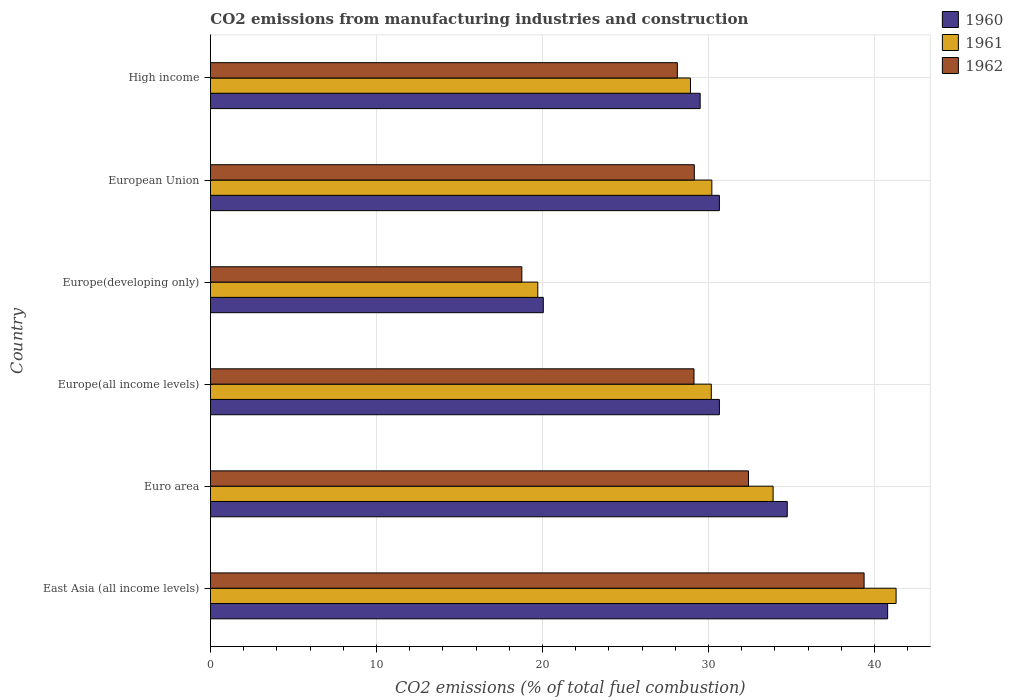How many different coloured bars are there?
Ensure brevity in your answer.  3. How many groups of bars are there?
Ensure brevity in your answer.  6. Are the number of bars per tick equal to the number of legend labels?
Provide a short and direct response. Yes. How many bars are there on the 5th tick from the bottom?
Keep it short and to the point. 3. What is the label of the 4th group of bars from the top?
Offer a terse response. Europe(all income levels). In how many cases, is the number of bars for a given country not equal to the number of legend labels?
Offer a terse response. 0. What is the amount of CO2 emitted in 1962 in Europe(developing only)?
Keep it short and to the point. 18.76. Across all countries, what is the maximum amount of CO2 emitted in 1960?
Your response must be concise. 40.79. Across all countries, what is the minimum amount of CO2 emitted in 1962?
Your response must be concise. 18.76. In which country was the amount of CO2 emitted in 1961 maximum?
Provide a short and direct response. East Asia (all income levels). In which country was the amount of CO2 emitted in 1962 minimum?
Ensure brevity in your answer.  Europe(developing only). What is the total amount of CO2 emitted in 1961 in the graph?
Give a very brief answer. 184.19. What is the difference between the amount of CO2 emitted in 1962 in Euro area and that in High income?
Offer a terse response. 4.29. What is the difference between the amount of CO2 emitted in 1962 in East Asia (all income levels) and the amount of CO2 emitted in 1960 in Europe(developing only)?
Ensure brevity in your answer.  19.32. What is the average amount of CO2 emitted in 1961 per country?
Offer a very short reply. 30.7. What is the difference between the amount of CO2 emitted in 1962 and amount of CO2 emitted in 1961 in European Union?
Offer a very short reply. -1.05. What is the ratio of the amount of CO2 emitted in 1962 in Euro area to that in European Union?
Provide a short and direct response. 1.11. Is the amount of CO2 emitted in 1960 in Europe(developing only) less than that in European Union?
Your answer should be very brief. Yes. Is the difference between the amount of CO2 emitted in 1962 in Europe(all income levels) and High income greater than the difference between the amount of CO2 emitted in 1961 in Europe(all income levels) and High income?
Give a very brief answer. No. What is the difference between the highest and the second highest amount of CO2 emitted in 1962?
Give a very brief answer. 6.96. What is the difference between the highest and the lowest amount of CO2 emitted in 1962?
Your answer should be compact. 20.62. In how many countries, is the amount of CO2 emitted in 1961 greater than the average amount of CO2 emitted in 1961 taken over all countries?
Ensure brevity in your answer.  2. What does the 2nd bar from the top in Europe(all income levels) represents?
Offer a terse response. 1961. What does the 3rd bar from the bottom in East Asia (all income levels) represents?
Ensure brevity in your answer.  1962. How many bars are there?
Offer a very short reply. 18. Are all the bars in the graph horizontal?
Your answer should be very brief. Yes. What is the difference between two consecutive major ticks on the X-axis?
Ensure brevity in your answer.  10. Are the values on the major ticks of X-axis written in scientific E-notation?
Give a very brief answer. No. Does the graph contain grids?
Offer a terse response. Yes. Where does the legend appear in the graph?
Ensure brevity in your answer.  Top right. How are the legend labels stacked?
Offer a terse response. Vertical. What is the title of the graph?
Keep it short and to the point. CO2 emissions from manufacturing industries and construction. What is the label or title of the X-axis?
Your answer should be compact. CO2 emissions (% of total fuel combustion). What is the label or title of the Y-axis?
Your response must be concise. Country. What is the CO2 emissions (% of total fuel combustion) of 1960 in East Asia (all income levels)?
Offer a terse response. 40.79. What is the CO2 emissions (% of total fuel combustion) of 1961 in East Asia (all income levels)?
Offer a terse response. 41.3. What is the CO2 emissions (% of total fuel combustion) of 1962 in East Asia (all income levels)?
Provide a short and direct response. 39.37. What is the CO2 emissions (% of total fuel combustion) in 1960 in Euro area?
Ensure brevity in your answer.  34.75. What is the CO2 emissions (% of total fuel combustion) in 1961 in Euro area?
Your answer should be compact. 33.89. What is the CO2 emissions (% of total fuel combustion) in 1962 in Euro area?
Provide a short and direct response. 32.41. What is the CO2 emissions (% of total fuel combustion) of 1960 in Europe(all income levels)?
Your answer should be very brief. 30.66. What is the CO2 emissions (% of total fuel combustion) in 1961 in Europe(all income levels)?
Ensure brevity in your answer.  30.17. What is the CO2 emissions (% of total fuel combustion) of 1962 in Europe(all income levels)?
Your answer should be very brief. 29.13. What is the CO2 emissions (% of total fuel combustion) in 1960 in Europe(developing only)?
Your answer should be compact. 20.05. What is the CO2 emissions (% of total fuel combustion) in 1961 in Europe(developing only)?
Offer a very short reply. 19.72. What is the CO2 emissions (% of total fuel combustion) in 1962 in Europe(developing only)?
Your answer should be very brief. 18.76. What is the CO2 emissions (% of total fuel combustion) in 1960 in European Union?
Ensure brevity in your answer.  30.66. What is the CO2 emissions (% of total fuel combustion) in 1961 in European Union?
Your response must be concise. 30.2. What is the CO2 emissions (% of total fuel combustion) of 1962 in European Union?
Offer a very short reply. 29.15. What is the CO2 emissions (% of total fuel combustion) of 1960 in High income?
Ensure brevity in your answer.  29.5. What is the CO2 emissions (% of total fuel combustion) of 1961 in High income?
Make the answer very short. 28.92. What is the CO2 emissions (% of total fuel combustion) of 1962 in High income?
Offer a terse response. 28.12. Across all countries, what is the maximum CO2 emissions (% of total fuel combustion) of 1960?
Give a very brief answer. 40.79. Across all countries, what is the maximum CO2 emissions (% of total fuel combustion) in 1961?
Give a very brief answer. 41.3. Across all countries, what is the maximum CO2 emissions (% of total fuel combustion) of 1962?
Provide a short and direct response. 39.37. Across all countries, what is the minimum CO2 emissions (% of total fuel combustion) in 1960?
Your response must be concise. 20.05. Across all countries, what is the minimum CO2 emissions (% of total fuel combustion) of 1961?
Give a very brief answer. 19.72. Across all countries, what is the minimum CO2 emissions (% of total fuel combustion) in 1962?
Keep it short and to the point. 18.76. What is the total CO2 emissions (% of total fuel combustion) in 1960 in the graph?
Offer a very short reply. 186.4. What is the total CO2 emissions (% of total fuel combustion) in 1961 in the graph?
Make the answer very short. 184.19. What is the total CO2 emissions (% of total fuel combustion) of 1962 in the graph?
Offer a very short reply. 176.93. What is the difference between the CO2 emissions (% of total fuel combustion) in 1960 in East Asia (all income levels) and that in Euro area?
Your response must be concise. 6.05. What is the difference between the CO2 emissions (% of total fuel combustion) of 1961 in East Asia (all income levels) and that in Euro area?
Your response must be concise. 7.41. What is the difference between the CO2 emissions (% of total fuel combustion) in 1962 in East Asia (all income levels) and that in Euro area?
Give a very brief answer. 6.96. What is the difference between the CO2 emissions (% of total fuel combustion) of 1960 in East Asia (all income levels) and that in Europe(all income levels)?
Ensure brevity in your answer.  10.13. What is the difference between the CO2 emissions (% of total fuel combustion) in 1961 in East Asia (all income levels) and that in Europe(all income levels)?
Keep it short and to the point. 11.13. What is the difference between the CO2 emissions (% of total fuel combustion) of 1962 in East Asia (all income levels) and that in Europe(all income levels)?
Your response must be concise. 10.25. What is the difference between the CO2 emissions (% of total fuel combustion) of 1960 in East Asia (all income levels) and that in Europe(developing only)?
Make the answer very short. 20.74. What is the difference between the CO2 emissions (% of total fuel combustion) of 1961 in East Asia (all income levels) and that in Europe(developing only)?
Offer a terse response. 21.58. What is the difference between the CO2 emissions (% of total fuel combustion) in 1962 in East Asia (all income levels) and that in Europe(developing only)?
Keep it short and to the point. 20.62. What is the difference between the CO2 emissions (% of total fuel combustion) in 1960 in East Asia (all income levels) and that in European Union?
Your answer should be very brief. 10.13. What is the difference between the CO2 emissions (% of total fuel combustion) in 1961 in East Asia (all income levels) and that in European Union?
Provide a succinct answer. 11.1. What is the difference between the CO2 emissions (% of total fuel combustion) of 1962 in East Asia (all income levels) and that in European Union?
Give a very brief answer. 10.23. What is the difference between the CO2 emissions (% of total fuel combustion) of 1960 in East Asia (all income levels) and that in High income?
Provide a short and direct response. 11.29. What is the difference between the CO2 emissions (% of total fuel combustion) of 1961 in East Asia (all income levels) and that in High income?
Provide a short and direct response. 12.38. What is the difference between the CO2 emissions (% of total fuel combustion) of 1962 in East Asia (all income levels) and that in High income?
Keep it short and to the point. 11.25. What is the difference between the CO2 emissions (% of total fuel combustion) in 1960 in Euro area and that in Europe(all income levels)?
Offer a terse response. 4.09. What is the difference between the CO2 emissions (% of total fuel combustion) of 1961 in Euro area and that in Europe(all income levels)?
Your answer should be very brief. 3.72. What is the difference between the CO2 emissions (% of total fuel combustion) of 1962 in Euro area and that in Europe(all income levels)?
Offer a terse response. 3.28. What is the difference between the CO2 emissions (% of total fuel combustion) of 1960 in Euro area and that in Europe(developing only)?
Your answer should be very brief. 14.7. What is the difference between the CO2 emissions (% of total fuel combustion) of 1961 in Euro area and that in Europe(developing only)?
Ensure brevity in your answer.  14.18. What is the difference between the CO2 emissions (% of total fuel combustion) of 1962 in Euro area and that in Europe(developing only)?
Make the answer very short. 13.65. What is the difference between the CO2 emissions (% of total fuel combustion) of 1960 in Euro area and that in European Union?
Your response must be concise. 4.09. What is the difference between the CO2 emissions (% of total fuel combustion) in 1961 in Euro area and that in European Union?
Offer a very short reply. 3.69. What is the difference between the CO2 emissions (% of total fuel combustion) of 1962 in Euro area and that in European Union?
Your answer should be very brief. 3.26. What is the difference between the CO2 emissions (% of total fuel combustion) of 1960 in Euro area and that in High income?
Your response must be concise. 5.25. What is the difference between the CO2 emissions (% of total fuel combustion) of 1961 in Euro area and that in High income?
Offer a very short reply. 4.98. What is the difference between the CO2 emissions (% of total fuel combustion) of 1962 in Euro area and that in High income?
Ensure brevity in your answer.  4.29. What is the difference between the CO2 emissions (% of total fuel combustion) of 1960 in Europe(all income levels) and that in Europe(developing only)?
Your answer should be compact. 10.61. What is the difference between the CO2 emissions (% of total fuel combustion) of 1961 in Europe(all income levels) and that in Europe(developing only)?
Your answer should be compact. 10.45. What is the difference between the CO2 emissions (% of total fuel combustion) in 1962 in Europe(all income levels) and that in Europe(developing only)?
Your answer should be very brief. 10.37. What is the difference between the CO2 emissions (% of total fuel combustion) of 1960 in Europe(all income levels) and that in European Union?
Provide a succinct answer. 0. What is the difference between the CO2 emissions (% of total fuel combustion) of 1961 in Europe(all income levels) and that in European Union?
Offer a terse response. -0.03. What is the difference between the CO2 emissions (% of total fuel combustion) in 1962 in Europe(all income levels) and that in European Union?
Ensure brevity in your answer.  -0.02. What is the difference between the CO2 emissions (% of total fuel combustion) of 1960 in Europe(all income levels) and that in High income?
Your answer should be compact. 1.16. What is the difference between the CO2 emissions (% of total fuel combustion) in 1961 in Europe(all income levels) and that in High income?
Give a very brief answer. 1.25. What is the difference between the CO2 emissions (% of total fuel combustion) in 1960 in Europe(developing only) and that in European Union?
Keep it short and to the point. -10.61. What is the difference between the CO2 emissions (% of total fuel combustion) in 1961 in Europe(developing only) and that in European Union?
Ensure brevity in your answer.  -10.48. What is the difference between the CO2 emissions (% of total fuel combustion) in 1962 in Europe(developing only) and that in European Union?
Make the answer very short. -10.39. What is the difference between the CO2 emissions (% of total fuel combustion) in 1960 in Europe(developing only) and that in High income?
Make the answer very short. -9.45. What is the difference between the CO2 emissions (% of total fuel combustion) of 1961 in Europe(developing only) and that in High income?
Offer a terse response. -9.2. What is the difference between the CO2 emissions (% of total fuel combustion) in 1962 in Europe(developing only) and that in High income?
Keep it short and to the point. -9.37. What is the difference between the CO2 emissions (% of total fuel combustion) of 1960 in European Union and that in High income?
Keep it short and to the point. 1.16. What is the difference between the CO2 emissions (% of total fuel combustion) of 1961 in European Union and that in High income?
Your answer should be compact. 1.29. What is the difference between the CO2 emissions (% of total fuel combustion) of 1962 in European Union and that in High income?
Ensure brevity in your answer.  1.02. What is the difference between the CO2 emissions (% of total fuel combustion) in 1960 in East Asia (all income levels) and the CO2 emissions (% of total fuel combustion) in 1961 in Euro area?
Ensure brevity in your answer.  6.9. What is the difference between the CO2 emissions (% of total fuel combustion) of 1960 in East Asia (all income levels) and the CO2 emissions (% of total fuel combustion) of 1962 in Euro area?
Your answer should be very brief. 8.38. What is the difference between the CO2 emissions (% of total fuel combustion) of 1961 in East Asia (all income levels) and the CO2 emissions (% of total fuel combustion) of 1962 in Euro area?
Give a very brief answer. 8.89. What is the difference between the CO2 emissions (% of total fuel combustion) in 1960 in East Asia (all income levels) and the CO2 emissions (% of total fuel combustion) in 1961 in Europe(all income levels)?
Provide a short and direct response. 10.62. What is the difference between the CO2 emissions (% of total fuel combustion) of 1960 in East Asia (all income levels) and the CO2 emissions (% of total fuel combustion) of 1962 in Europe(all income levels)?
Your answer should be compact. 11.66. What is the difference between the CO2 emissions (% of total fuel combustion) of 1961 in East Asia (all income levels) and the CO2 emissions (% of total fuel combustion) of 1962 in Europe(all income levels)?
Your answer should be compact. 12.17. What is the difference between the CO2 emissions (% of total fuel combustion) in 1960 in East Asia (all income levels) and the CO2 emissions (% of total fuel combustion) in 1961 in Europe(developing only)?
Your answer should be very brief. 21.07. What is the difference between the CO2 emissions (% of total fuel combustion) in 1960 in East Asia (all income levels) and the CO2 emissions (% of total fuel combustion) in 1962 in Europe(developing only)?
Ensure brevity in your answer.  22.03. What is the difference between the CO2 emissions (% of total fuel combustion) in 1961 in East Asia (all income levels) and the CO2 emissions (% of total fuel combustion) in 1962 in Europe(developing only)?
Your answer should be compact. 22.54. What is the difference between the CO2 emissions (% of total fuel combustion) of 1960 in East Asia (all income levels) and the CO2 emissions (% of total fuel combustion) of 1961 in European Union?
Make the answer very short. 10.59. What is the difference between the CO2 emissions (% of total fuel combustion) in 1960 in East Asia (all income levels) and the CO2 emissions (% of total fuel combustion) in 1962 in European Union?
Give a very brief answer. 11.64. What is the difference between the CO2 emissions (% of total fuel combustion) in 1961 in East Asia (all income levels) and the CO2 emissions (% of total fuel combustion) in 1962 in European Union?
Ensure brevity in your answer.  12.15. What is the difference between the CO2 emissions (% of total fuel combustion) of 1960 in East Asia (all income levels) and the CO2 emissions (% of total fuel combustion) of 1961 in High income?
Keep it short and to the point. 11.88. What is the difference between the CO2 emissions (% of total fuel combustion) of 1960 in East Asia (all income levels) and the CO2 emissions (% of total fuel combustion) of 1962 in High income?
Provide a short and direct response. 12.67. What is the difference between the CO2 emissions (% of total fuel combustion) of 1961 in East Asia (all income levels) and the CO2 emissions (% of total fuel combustion) of 1962 in High income?
Offer a very short reply. 13.18. What is the difference between the CO2 emissions (% of total fuel combustion) of 1960 in Euro area and the CO2 emissions (% of total fuel combustion) of 1961 in Europe(all income levels)?
Give a very brief answer. 4.58. What is the difference between the CO2 emissions (% of total fuel combustion) of 1960 in Euro area and the CO2 emissions (% of total fuel combustion) of 1962 in Europe(all income levels)?
Ensure brevity in your answer.  5.62. What is the difference between the CO2 emissions (% of total fuel combustion) in 1961 in Euro area and the CO2 emissions (% of total fuel combustion) in 1962 in Europe(all income levels)?
Your answer should be very brief. 4.77. What is the difference between the CO2 emissions (% of total fuel combustion) in 1960 in Euro area and the CO2 emissions (% of total fuel combustion) in 1961 in Europe(developing only)?
Provide a succinct answer. 15.03. What is the difference between the CO2 emissions (% of total fuel combustion) of 1960 in Euro area and the CO2 emissions (% of total fuel combustion) of 1962 in Europe(developing only)?
Provide a succinct answer. 15.99. What is the difference between the CO2 emissions (% of total fuel combustion) of 1961 in Euro area and the CO2 emissions (% of total fuel combustion) of 1962 in Europe(developing only)?
Your answer should be compact. 15.14. What is the difference between the CO2 emissions (% of total fuel combustion) in 1960 in Euro area and the CO2 emissions (% of total fuel combustion) in 1961 in European Union?
Give a very brief answer. 4.54. What is the difference between the CO2 emissions (% of total fuel combustion) in 1960 in Euro area and the CO2 emissions (% of total fuel combustion) in 1962 in European Union?
Your answer should be compact. 5.6. What is the difference between the CO2 emissions (% of total fuel combustion) in 1961 in Euro area and the CO2 emissions (% of total fuel combustion) in 1962 in European Union?
Keep it short and to the point. 4.75. What is the difference between the CO2 emissions (% of total fuel combustion) in 1960 in Euro area and the CO2 emissions (% of total fuel combustion) in 1961 in High income?
Your response must be concise. 5.83. What is the difference between the CO2 emissions (% of total fuel combustion) of 1960 in Euro area and the CO2 emissions (% of total fuel combustion) of 1962 in High income?
Your answer should be compact. 6.62. What is the difference between the CO2 emissions (% of total fuel combustion) in 1961 in Euro area and the CO2 emissions (% of total fuel combustion) in 1962 in High income?
Offer a terse response. 5.77. What is the difference between the CO2 emissions (% of total fuel combustion) of 1960 in Europe(all income levels) and the CO2 emissions (% of total fuel combustion) of 1961 in Europe(developing only)?
Offer a terse response. 10.94. What is the difference between the CO2 emissions (% of total fuel combustion) in 1961 in Europe(all income levels) and the CO2 emissions (% of total fuel combustion) in 1962 in Europe(developing only)?
Ensure brevity in your answer.  11.41. What is the difference between the CO2 emissions (% of total fuel combustion) of 1960 in Europe(all income levels) and the CO2 emissions (% of total fuel combustion) of 1961 in European Union?
Ensure brevity in your answer.  0.46. What is the difference between the CO2 emissions (% of total fuel combustion) in 1960 in Europe(all income levels) and the CO2 emissions (% of total fuel combustion) in 1962 in European Union?
Offer a very short reply. 1.51. What is the difference between the CO2 emissions (% of total fuel combustion) of 1961 in Europe(all income levels) and the CO2 emissions (% of total fuel combustion) of 1962 in European Union?
Keep it short and to the point. 1.02. What is the difference between the CO2 emissions (% of total fuel combustion) of 1960 in Europe(all income levels) and the CO2 emissions (% of total fuel combustion) of 1961 in High income?
Keep it short and to the point. 1.74. What is the difference between the CO2 emissions (% of total fuel combustion) of 1960 in Europe(all income levels) and the CO2 emissions (% of total fuel combustion) of 1962 in High income?
Keep it short and to the point. 2.53. What is the difference between the CO2 emissions (% of total fuel combustion) of 1961 in Europe(all income levels) and the CO2 emissions (% of total fuel combustion) of 1962 in High income?
Provide a short and direct response. 2.05. What is the difference between the CO2 emissions (% of total fuel combustion) of 1960 in Europe(developing only) and the CO2 emissions (% of total fuel combustion) of 1961 in European Union?
Make the answer very short. -10.15. What is the difference between the CO2 emissions (% of total fuel combustion) in 1960 in Europe(developing only) and the CO2 emissions (% of total fuel combustion) in 1962 in European Union?
Offer a terse response. -9.1. What is the difference between the CO2 emissions (% of total fuel combustion) in 1961 in Europe(developing only) and the CO2 emissions (% of total fuel combustion) in 1962 in European Union?
Ensure brevity in your answer.  -9.43. What is the difference between the CO2 emissions (% of total fuel combustion) in 1960 in Europe(developing only) and the CO2 emissions (% of total fuel combustion) in 1961 in High income?
Your response must be concise. -8.87. What is the difference between the CO2 emissions (% of total fuel combustion) of 1960 in Europe(developing only) and the CO2 emissions (% of total fuel combustion) of 1962 in High income?
Offer a very short reply. -8.07. What is the difference between the CO2 emissions (% of total fuel combustion) in 1961 in Europe(developing only) and the CO2 emissions (% of total fuel combustion) in 1962 in High income?
Your answer should be compact. -8.41. What is the difference between the CO2 emissions (% of total fuel combustion) in 1960 in European Union and the CO2 emissions (% of total fuel combustion) in 1961 in High income?
Give a very brief answer. 1.74. What is the difference between the CO2 emissions (% of total fuel combustion) in 1960 in European Union and the CO2 emissions (% of total fuel combustion) in 1962 in High income?
Ensure brevity in your answer.  2.53. What is the difference between the CO2 emissions (% of total fuel combustion) in 1961 in European Union and the CO2 emissions (% of total fuel combustion) in 1962 in High income?
Your response must be concise. 2.08. What is the average CO2 emissions (% of total fuel combustion) of 1960 per country?
Your response must be concise. 31.07. What is the average CO2 emissions (% of total fuel combustion) in 1961 per country?
Give a very brief answer. 30.7. What is the average CO2 emissions (% of total fuel combustion) of 1962 per country?
Offer a terse response. 29.49. What is the difference between the CO2 emissions (% of total fuel combustion) of 1960 and CO2 emissions (% of total fuel combustion) of 1961 in East Asia (all income levels)?
Offer a very short reply. -0.51. What is the difference between the CO2 emissions (% of total fuel combustion) of 1960 and CO2 emissions (% of total fuel combustion) of 1962 in East Asia (all income levels)?
Offer a terse response. 1.42. What is the difference between the CO2 emissions (% of total fuel combustion) in 1961 and CO2 emissions (% of total fuel combustion) in 1962 in East Asia (all income levels)?
Offer a terse response. 1.93. What is the difference between the CO2 emissions (% of total fuel combustion) in 1960 and CO2 emissions (% of total fuel combustion) in 1961 in Euro area?
Offer a very short reply. 0.85. What is the difference between the CO2 emissions (% of total fuel combustion) of 1960 and CO2 emissions (% of total fuel combustion) of 1962 in Euro area?
Keep it short and to the point. 2.34. What is the difference between the CO2 emissions (% of total fuel combustion) in 1961 and CO2 emissions (% of total fuel combustion) in 1962 in Euro area?
Provide a succinct answer. 1.48. What is the difference between the CO2 emissions (% of total fuel combustion) of 1960 and CO2 emissions (% of total fuel combustion) of 1961 in Europe(all income levels)?
Ensure brevity in your answer.  0.49. What is the difference between the CO2 emissions (% of total fuel combustion) in 1960 and CO2 emissions (% of total fuel combustion) in 1962 in Europe(all income levels)?
Your response must be concise. 1.53. What is the difference between the CO2 emissions (% of total fuel combustion) of 1961 and CO2 emissions (% of total fuel combustion) of 1962 in Europe(all income levels)?
Make the answer very short. 1.04. What is the difference between the CO2 emissions (% of total fuel combustion) in 1960 and CO2 emissions (% of total fuel combustion) in 1961 in Europe(developing only)?
Give a very brief answer. 0.33. What is the difference between the CO2 emissions (% of total fuel combustion) of 1960 and CO2 emissions (% of total fuel combustion) of 1962 in Europe(developing only)?
Your answer should be very brief. 1.29. What is the difference between the CO2 emissions (% of total fuel combustion) of 1961 and CO2 emissions (% of total fuel combustion) of 1962 in Europe(developing only)?
Provide a succinct answer. 0.96. What is the difference between the CO2 emissions (% of total fuel combustion) of 1960 and CO2 emissions (% of total fuel combustion) of 1961 in European Union?
Offer a terse response. 0.46. What is the difference between the CO2 emissions (% of total fuel combustion) in 1960 and CO2 emissions (% of total fuel combustion) in 1962 in European Union?
Make the answer very short. 1.51. What is the difference between the CO2 emissions (% of total fuel combustion) in 1961 and CO2 emissions (% of total fuel combustion) in 1962 in European Union?
Keep it short and to the point. 1.05. What is the difference between the CO2 emissions (% of total fuel combustion) of 1960 and CO2 emissions (% of total fuel combustion) of 1961 in High income?
Offer a very short reply. 0.58. What is the difference between the CO2 emissions (% of total fuel combustion) of 1960 and CO2 emissions (% of total fuel combustion) of 1962 in High income?
Keep it short and to the point. 1.37. What is the difference between the CO2 emissions (% of total fuel combustion) of 1961 and CO2 emissions (% of total fuel combustion) of 1962 in High income?
Your answer should be compact. 0.79. What is the ratio of the CO2 emissions (% of total fuel combustion) of 1960 in East Asia (all income levels) to that in Euro area?
Offer a terse response. 1.17. What is the ratio of the CO2 emissions (% of total fuel combustion) in 1961 in East Asia (all income levels) to that in Euro area?
Your answer should be compact. 1.22. What is the ratio of the CO2 emissions (% of total fuel combustion) in 1962 in East Asia (all income levels) to that in Euro area?
Keep it short and to the point. 1.21. What is the ratio of the CO2 emissions (% of total fuel combustion) in 1960 in East Asia (all income levels) to that in Europe(all income levels)?
Make the answer very short. 1.33. What is the ratio of the CO2 emissions (% of total fuel combustion) in 1961 in East Asia (all income levels) to that in Europe(all income levels)?
Your answer should be very brief. 1.37. What is the ratio of the CO2 emissions (% of total fuel combustion) in 1962 in East Asia (all income levels) to that in Europe(all income levels)?
Give a very brief answer. 1.35. What is the ratio of the CO2 emissions (% of total fuel combustion) of 1960 in East Asia (all income levels) to that in Europe(developing only)?
Offer a very short reply. 2.03. What is the ratio of the CO2 emissions (% of total fuel combustion) in 1961 in East Asia (all income levels) to that in Europe(developing only)?
Keep it short and to the point. 2.09. What is the ratio of the CO2 emissions (% of total fuel combustion) in 1962 in East Asia (all income levels) to that in Europe(developing only)?
Give a very brief answer. 2.1. What is the ratio of the CO2 emissions (% of total fuel combustion) in 1960 in East Asia (all income levels) to that in European Union?
Give a very brief answer. 1.33. What is the ratio of the CO2 emissions (% of total fuel combustion) in 1961 in East Asia (all income levels) to that in European Union?
Offer a very short reply. 1.37. What is the ratio of the CO2 emissions (% of total fuel combustion) of 1962 in East Asia (all income levels) to that in European Union?
Give a very brief answer. 1.35. What is the ratio of the CO2 emissions (% of total fuel combustion) in 1960 in East Asia (all income levels) to that in High income?
Make the answer very short. 1.38. What is the ratio of the CO2 emissions (% of total fuel combustion) in 1961 in East Asia (all income levels) to that in High income?
Provide a short and direct response. 1.43. What is the ratio of the CO2 emissions (% of total fuel combustion) in 1962 in East Asia (all income levels) to that in High income?
Ensure brevity in your answer.  1.4. What is the ratio of the CO2 emissions (% of total fuel combustion) of 1960 in Euro area to that in Europe(all income levels)?
Give a very brief answer. 1.13. What is the ratio of the CO2 emissions (% of total fuel combustion) of 1961 in Euro area to that in Europe(all income levels)?
Give a very brief answer. 1.12. What is the ratio of the CO2 emissions (% of total fuel combustion) in 1962 in Euro area to that in Europe(all income levels)?
Your answer should be compact. 1.11. What is the ratio of the CO2 emissions (% of total fuel combustion) in 1960 in Euro area to that in Europe(developing only)?
Offer a very short reply. 1.73. What is the ratio of the CO2 emissions (% of total fuel combustion) in 1961 in Euro area to that in Europe(developing only)?
Your answer should be very brief. 1.72. What is the ratio of the CO2 emissions (% of total fuel combustion) of 1962 in Euro area to that in Europe(developing only)?
Offer a terse response. 1.73. What is the ratio of the CO2 emissions (% of total fuel combustion) of 1960 in Euro area to that in European Union?
Make the answer very short. 1.13. What is the ratio of the CO2 emissions (% of total fuel combustion) in 1961 in Euro area to that in European Union?
Ensure brevity in your answer.  1.12. What is the ratio of the CO2 emissions (% of total fuel combustion) of 1962 in Euro area to that in European Union?
Your response must be concise. 1.11. What is the ratio of the CO2 emissions (% of total fuel combustion) in 1960 in Euro area to that in High income?
Give a very brief answer. 1.18. What is the ratio of the CO2 emissions (% of total fuel combustion) of 1961 in Euro area to that in High income?
Your response must be concise. 1.17. What is the ratio of the CO2 emissions (% of total fuel combustion) of 1962 in Euro area to that in High income?
Your response must be concise. 1.15. What is the ratio of the CO2 emissions (% of total fuel combustion) in 1960 in Europe(all income levels) to that in Europe(developing only)?
Keep it short and to the point. 1.53. What is the ratio of the CO2 emissions (% of total fuel combustion) in 1961 in Europe(all income levels) to that in Europe(developing only)?
Offer a terse response. 1.53. What is the ratio of the CO2 emissions (% of total fuel combustion) of 1962 in Europe(all income levels) to that in Europe(developing only)?
Provide a succinct answer. 1.55. What is the ratio of the CO2 emissions (% of total fuel combustion) of 1960 in Europe(all income levels) to that in European Union?
Ensure brevity in your answer.  1. What is the ratio of the CO2 emissions (% of total fuel combustion) in 1960 in Europe(all income levels) to that in High income?
Keep it short and to the point. 1.04. What is the ratio of the CO2 emissions (% of total fuel combustion) in 1961 in Europe(all income levels) to that in High income?
Make the answer very short. 1.04. What is the ratio of the CO2 emissions (% of total fuel combustion) of 1962 in Europe(all income levels) to that in High income?
Keep it short and to the point. 1.04. What is the ratio of the CO2 emissions (% of total fuel combustion) in 1960 in Europe(developing only) to that in European Union?
Your answer should be compact. 0.65. What is the ratio of the CO2 emissions (% of total fuel combustion) in 1961 in Europe(developing only) to that in European Union?
Give a very brief answer. 0.65. What is the ratio of the CO2 emissions (% of total fuel combustion) of 1962 in Europe(developing only) to that in European Union?
Your response must be concise. 0.64. What is the ratio of the CO2 emissions (% of total fuel combustion) in 1960 in Europe(developing only) to that in High income?
Provide a succinct answer. 0.68. What is the ratio of the CO2 emissions (% of total fuel combustion) of 1961 in Europe(developing only) to that in High income?
Your answer should be very brief. 0.68. What is the ratio of the CO2 emissions (% of total fuel combustion) of 1962 in Europe(developing only) to that in High income?
Make the answer very short. 0.67. What is the ratio of the CO2 emissions (% of total fuel combustion) in 1960 in European Union to that in High income?
Offer a terse response. 1.04. What is the ratio of the CO2 emissions (% of total fuel combustion) in 1961 in European Union to that in High income?
Keep it short and to the point. 1.04. What is the ratio of the CO2 emissions (% of total fuel combustion) of 1962 in European Union to that in High income?
Your answer should be compact. 1.04. What is the difference between the highest and the second highest CO2 emissions (% of total fuel combustion) of 1960?
Offer a terse response. 6.05. What is the difference between the highest and the second highest CO2 emissions (% of total fuel combustion) in 1961?
Make the answer very short. 7.41. What is the difference between the highest and the second highest CO2 emissions (% of total fuel combustion) in 1962?
Provide a succinct answer. 6.96. What is the difference between the highest and the lowest CO2 emissions (% of total fuel combustion) of 1960?
Your answer should be very brief. 20.74. What is the difference between the highest and the lowest CO2 emissions (% of total fuel combustion) in 1961?
Your answer should be compact. 21.58. What is the difference between the highest and the lowest CO2 emissions (% of total fuel combustion) in 1962?
Your answer should be very brief. 20.62. 